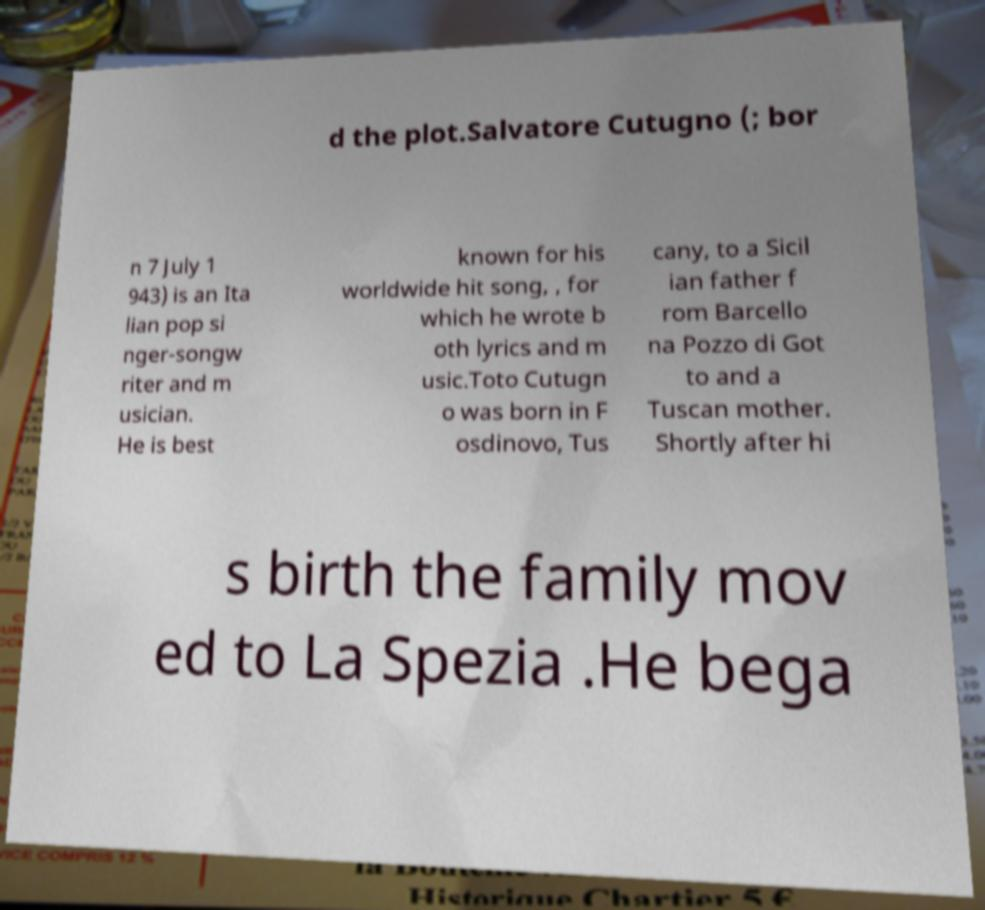There's text embedded in this image that I need extracted. Can you transcribe it verbatim? d the plot.Salvatore Cutugno (; bor n 7 July 1 943) is an Ita lian pop si nger-songw riter and m usician. He is best known for his worldwide hit song, , for which he wrote b oth lyrics and m usic.Toto Cutugn o was born in F osdinovo, Tus cany, to a Sicil ian father f rom Barcello na Pozzo di Got to and a Tuscan mother. Shortly after hi s birth the family mov ed to La Spezia .He bega 